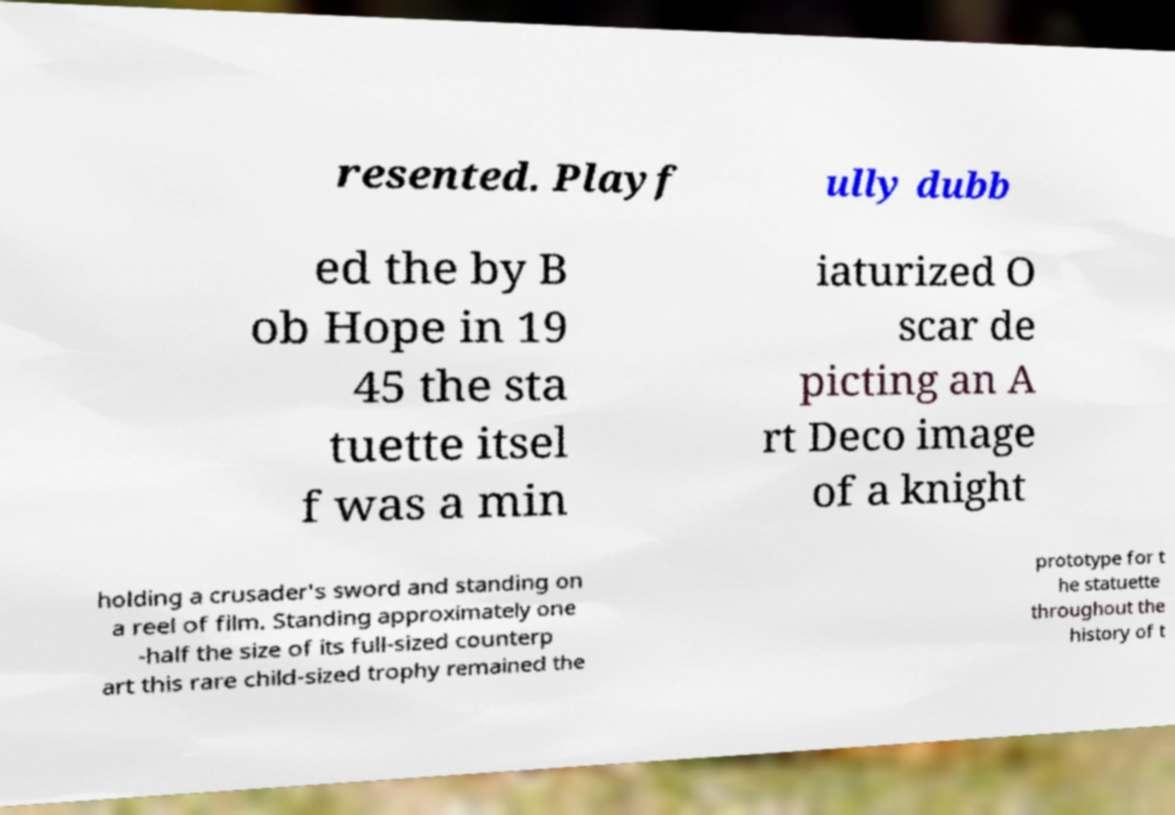Could you assist in decoding the text presented in this image and type it out clearly? resented. Playf ully dubb ed the by B ob Hope in 19 45 the sta tuette itsel f was a min iaturized O scar de picting an A rt Deco image of a knight holding a crusader's sword and standing on a reel of film. Standing approximately one -half the size of its full-sized counterp art this rare child-sized trophy remained the prototype for t he statuette throughout the history of t 